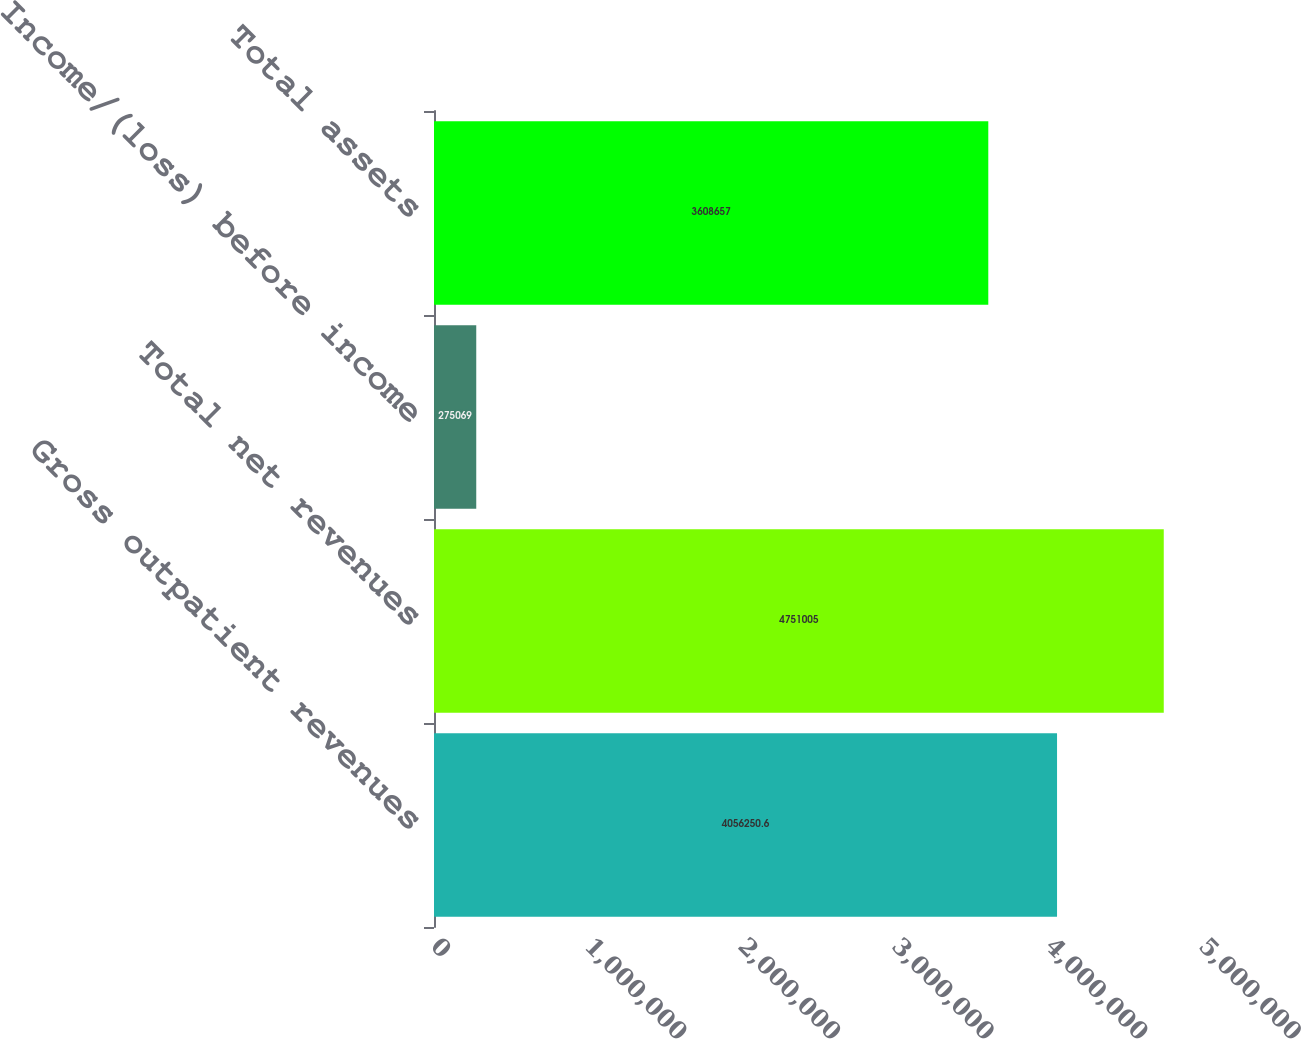Convert chart. <chart><loc_0><loc_0><loc_500><loc_500><bar_chart><fcel>Gross outpatient revenues<fcel>Total net revenues<fcel>Income/(loss) before income<fcel>Total assets<nl><fcel>4.05625e+06<fcel>4.751e+06<fcel>275069<fcel>3.60866e+06<nl></chart> 